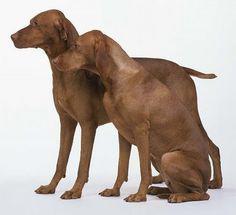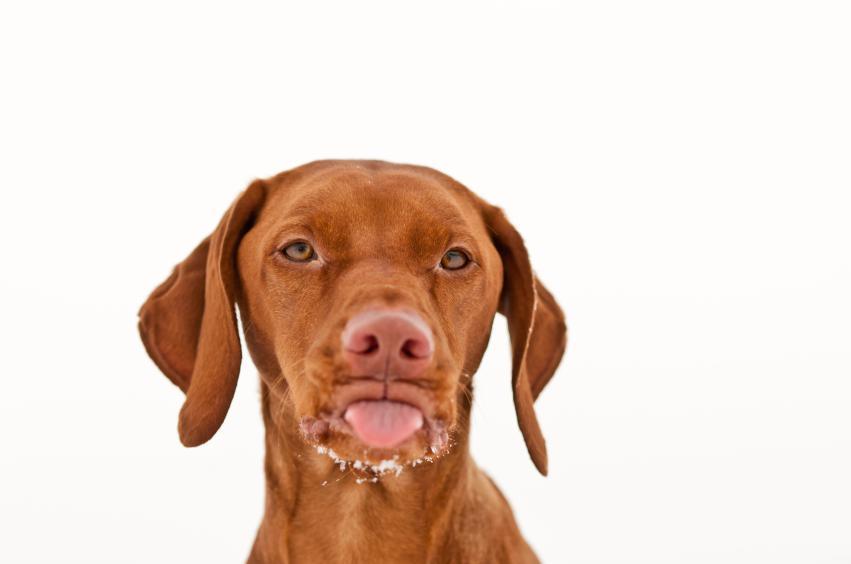The first image is the image on the left, the second image is the image on the right. Analyze the images presented: Is the assertion "The left image shows two leftward-facing red-orange dogs, and at least one of them is sitting upright." valid? Answer yes or no. Yes. The first image is the image on the left, the second image is the image on the right. For the images shown, is this caption "The left and right image contains the same number of dogs." true? Answer yes or no. No. 